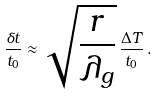Convert formula to latex. <formula><loc_0><loc_0><loc_500><loc_500>\frac { \delta t } { t _ { 0 } } \approx \sqrt { \frac { r } { \lambda _ { g } } } \, \frac { \Delta T } { t _ { 0 } } \, .</formula> 